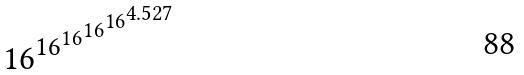<formula> <loc_0><loc_0><loc_500><loc_500>1 6 ^ { 1 6 ^ { 1 6 ^ { 1 6 ^ { 1 6 ^ { 4 . 5 2 7 } } } } }</formula> 